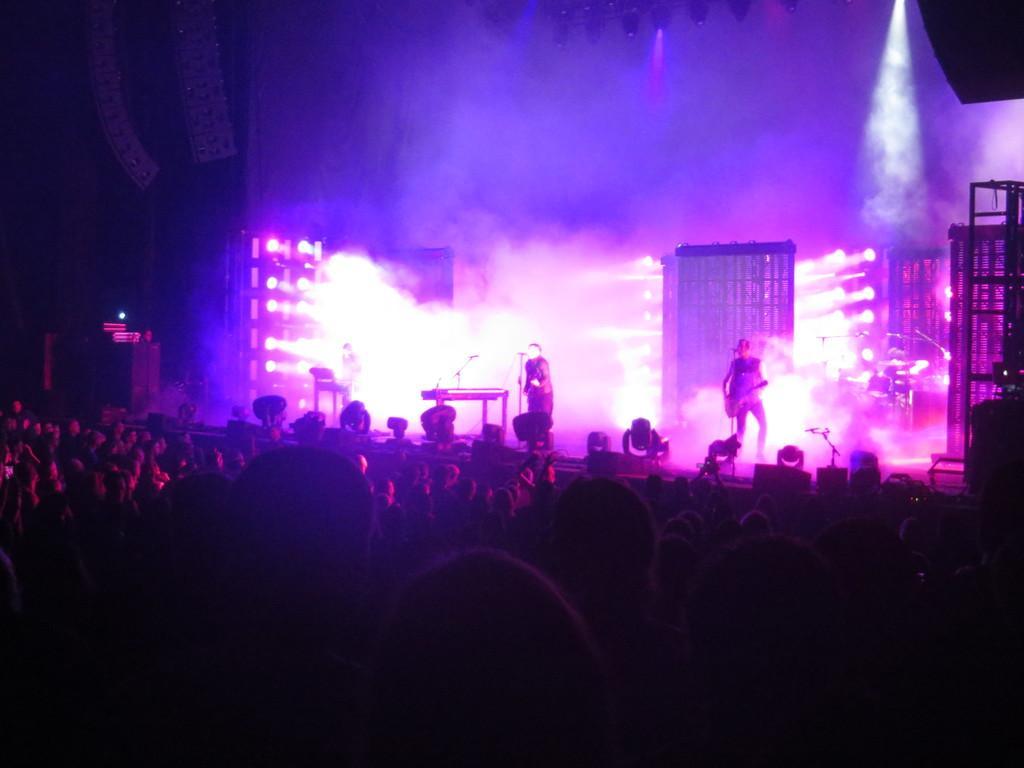Describe this image in one or two sentences. In this image we can see two people are standing on the stage and at the bottom of the image, a crowd of people is present. There are lights in the background of the image. 